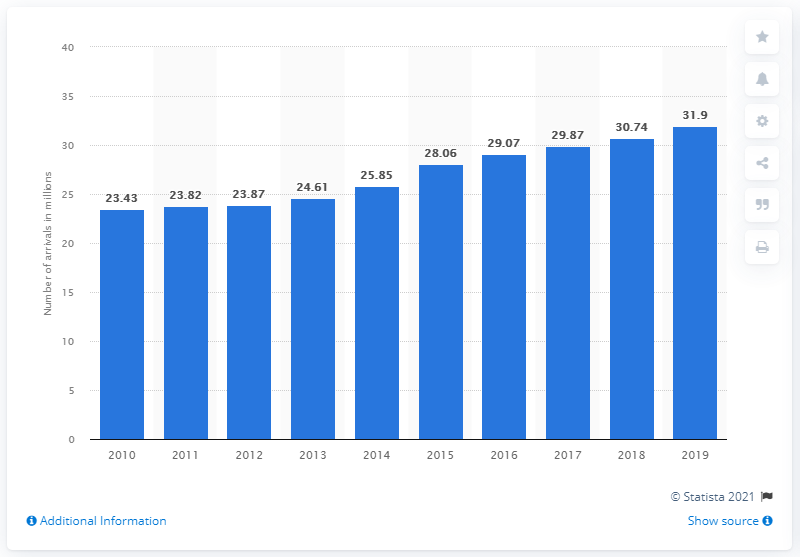Specify some key components in this picture. In 2019, an estimated 31.9 million people stayed at least one night in Swedish tourist accommodations. 